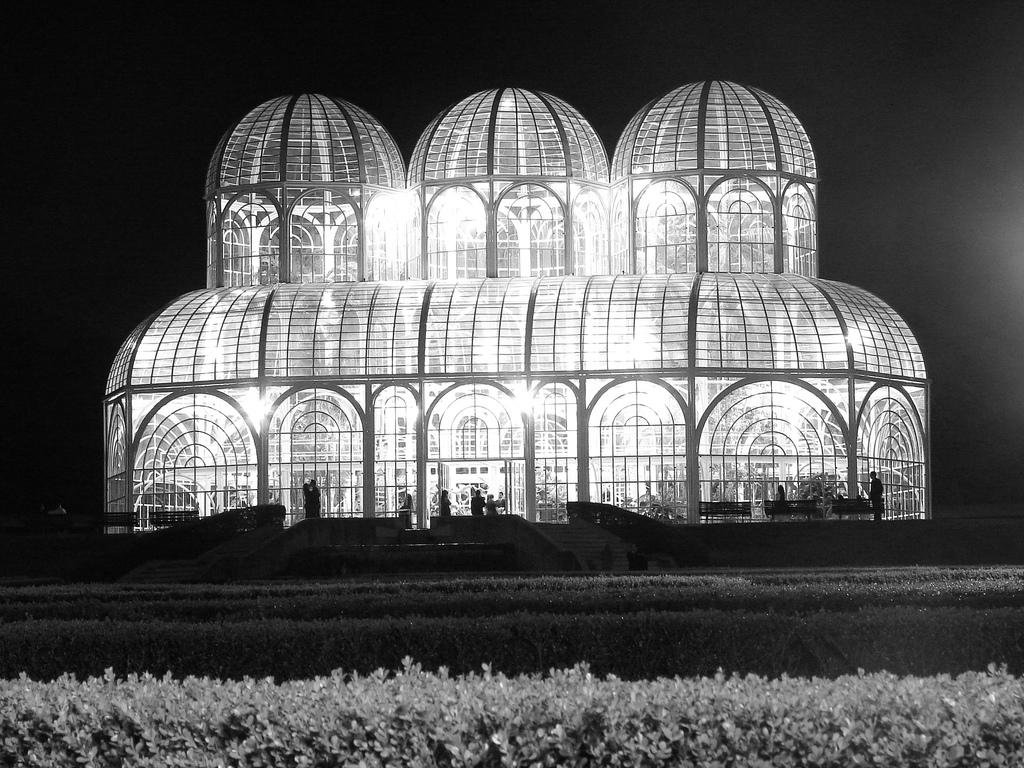What type of living organisms can be seen in the image? Plants can be seen in the image. What type of structure is present in the image? There is a building in the image. Who or what else is visible in the image? There are people in the image. What is the color of the background in the image? The background of the image is dark. Can you see a mountain in the background of the image? There is no mountain visible in the image; the background is dark and does not show any geographical features. 